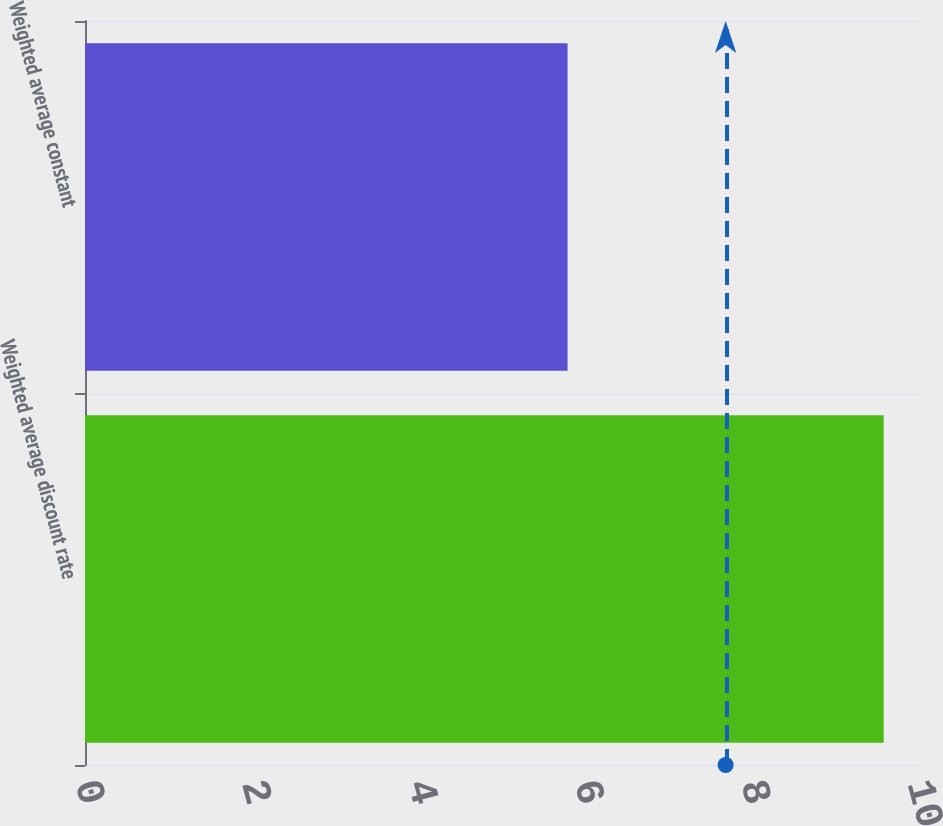Convert chart. <chart><loc_0><loc_0><loc_500><loc_500><bar_chart><fcel>Weighted average discount rate<fcel>Weighted average constant<nl><fcel>9.6<fcel>5.8<nl></chart> 